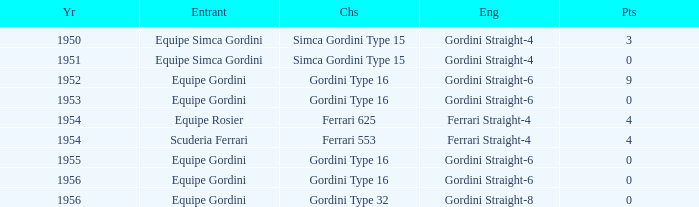How many points after 1956? 0.0. 